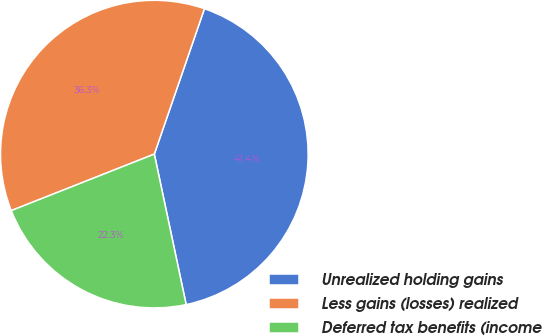Convert chart. <chart><loc_0><loc_0><loc_500><loc_500><pie_chart><fcel>Unrealized holding gains<fcel>Less gains (losses) realized<fcel>Deferred tax benefits (income<nl><fcel>41.4%<fcel>36.27%<fcel>22.33%<nl></chart> 